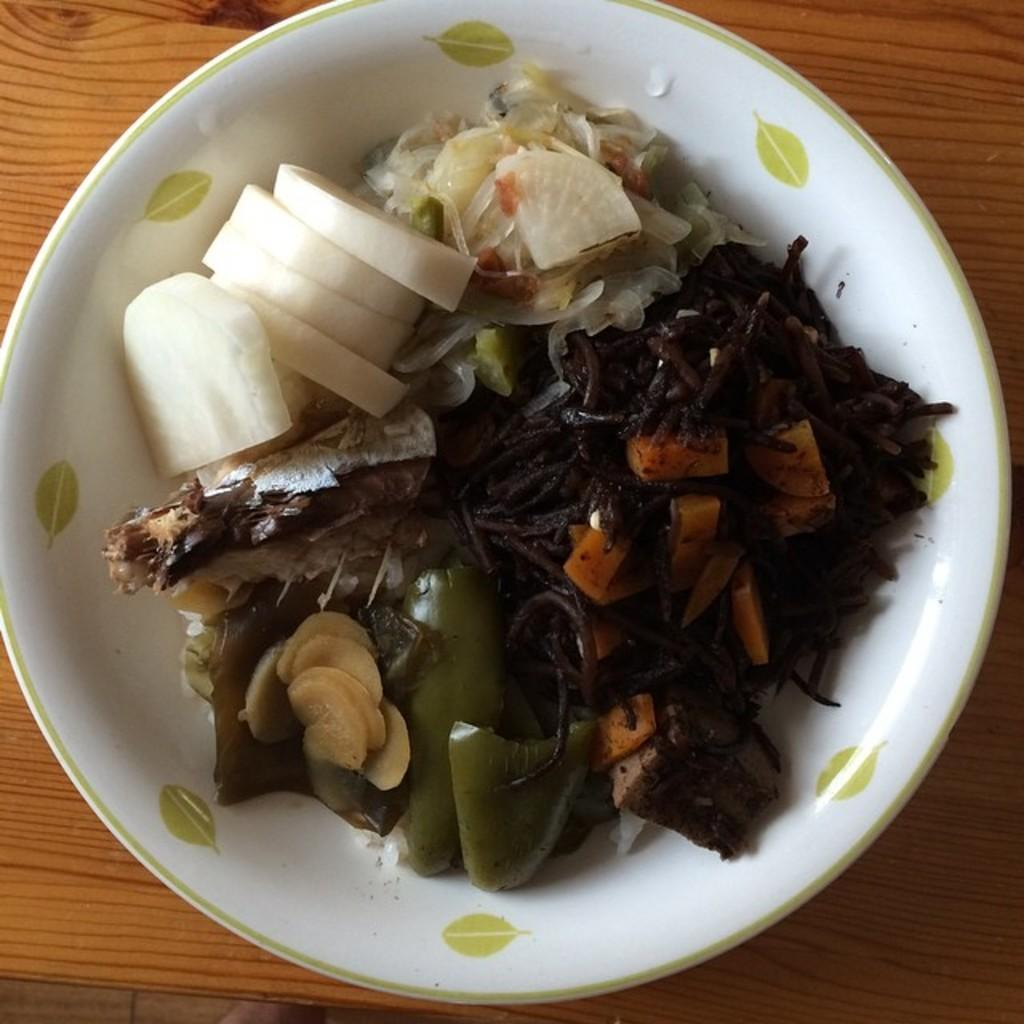What is the main object in the image? There is a bowl in the image. Where is the bowl located? The bowl is on a wooden table. What is inside the bowl? There are various food items in the bowl. How many cakes are on the queen's car in the image? There are no cakes, queens, or cars present in the image. 